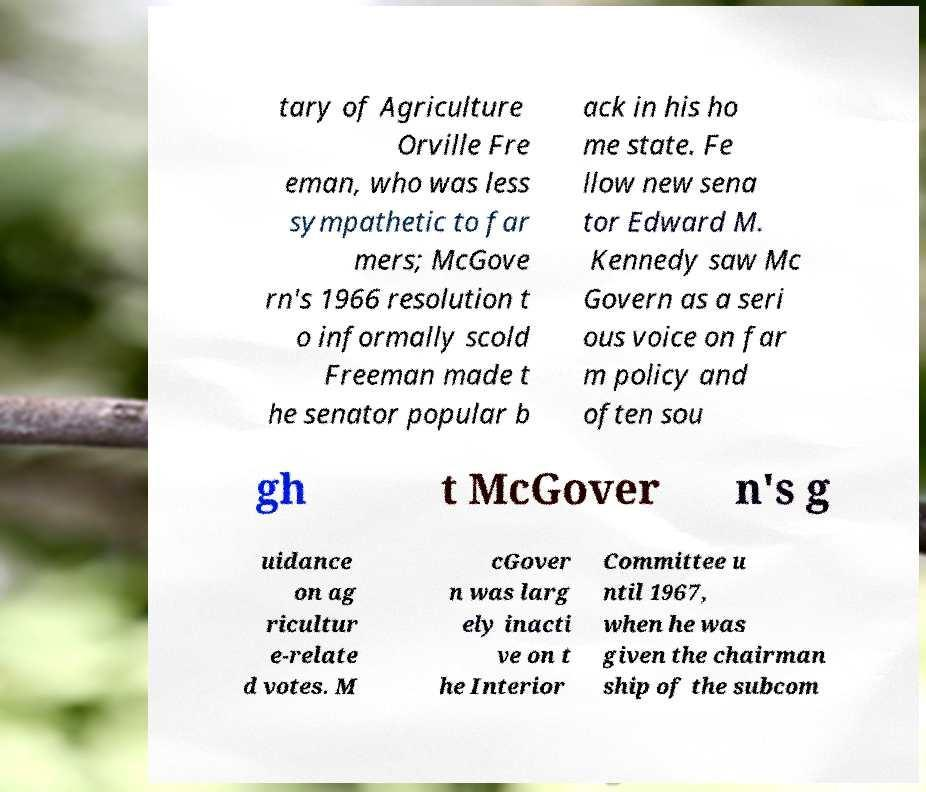Please identify and transcribe the text found in this image. tary of Agriculture Orville Fre eman, who was less sympathetic to far mers; McGove rn's 1966 resolution t o informally scold Freeman made t he senator popular b ack in his ho me state. Fe llow new sena tor Edward M. Kennedy saw Mc Govern as a seri ous voice on far m policy and often sou gh t McGover n's g uidance on ag ricultur e-relate d votes. M cGover n was larg ely inacti ve on t he Interior Committee u ntil 1967, when he was given the chairman ship of the subcom 